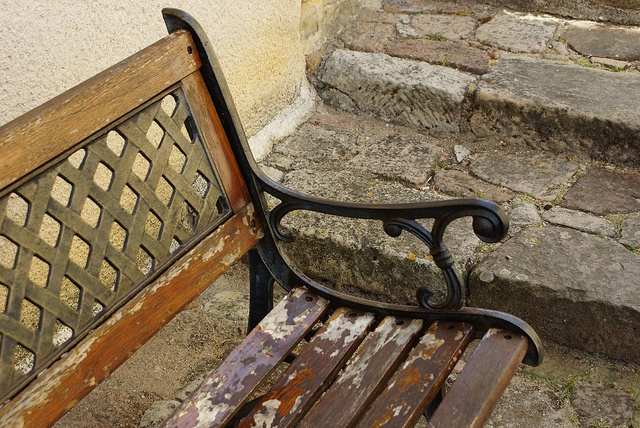Describe the objects in this image and their specific colors. I can see a bench in lightgray, black, gray, and tan tones in this image. 